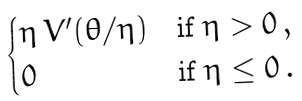<formula> <loc_0><loc_0><loc_500><loc_500>\begin{cases} \eta \, V ^ { \prime } ( \theta / \eta ) & \text {if } \eta > 0 \, , \\ 0 & \text {if } \eta \leq 0 \, . \end{cases}</formula> 